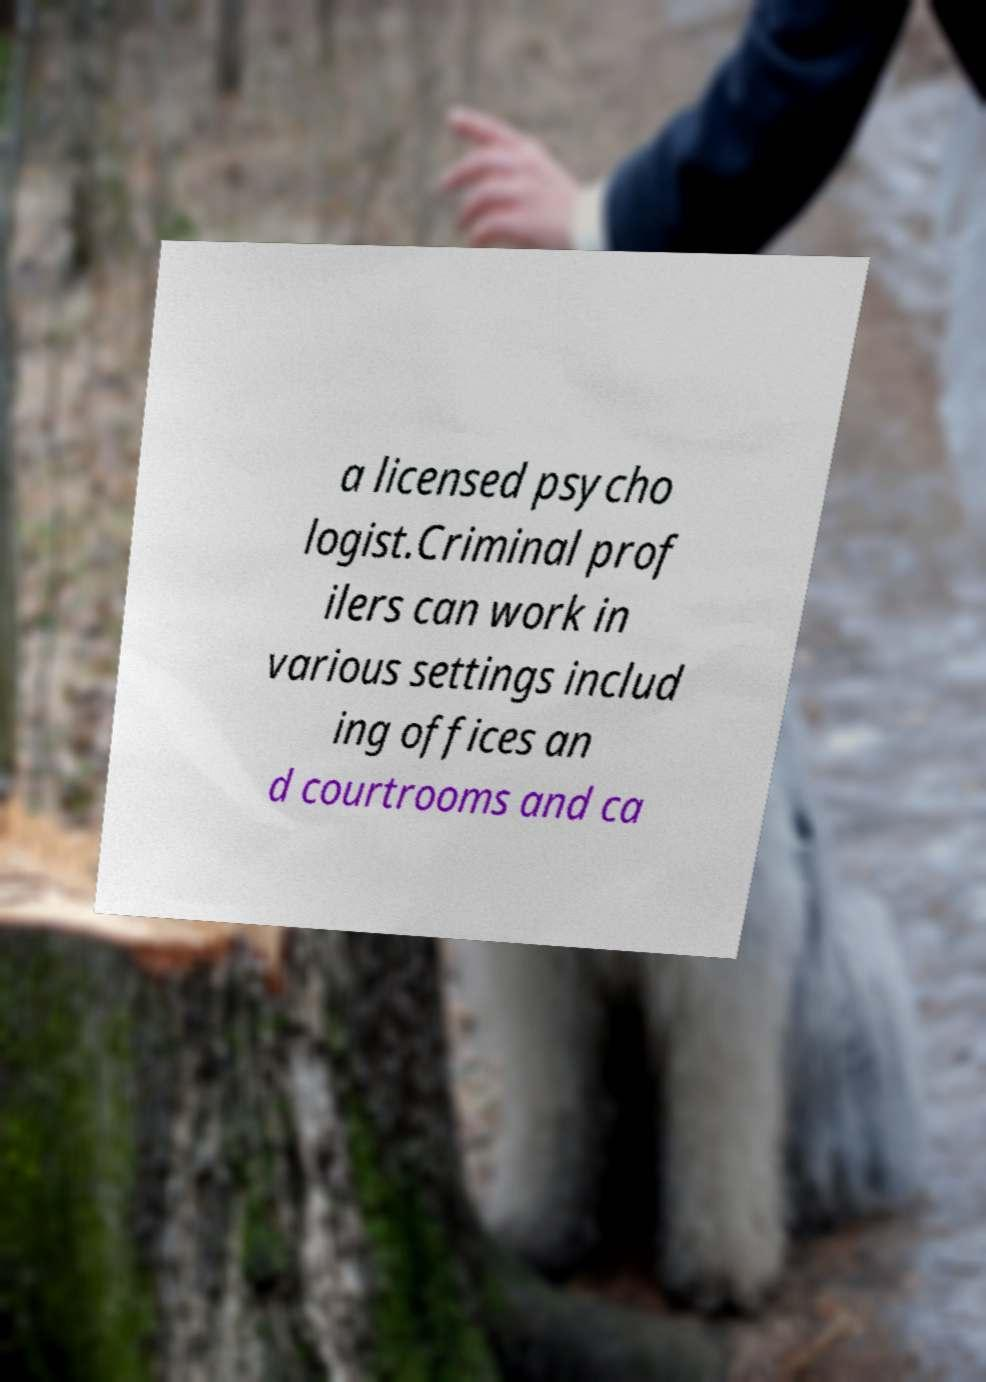Can you read and provide the text displayed in the image?This photo seems to have some interesting text. Can you extract and type it out for me? a licensed psycho logist.Criminal prof ilers can work in various settings includ ing offices an d courtrooms and ca 